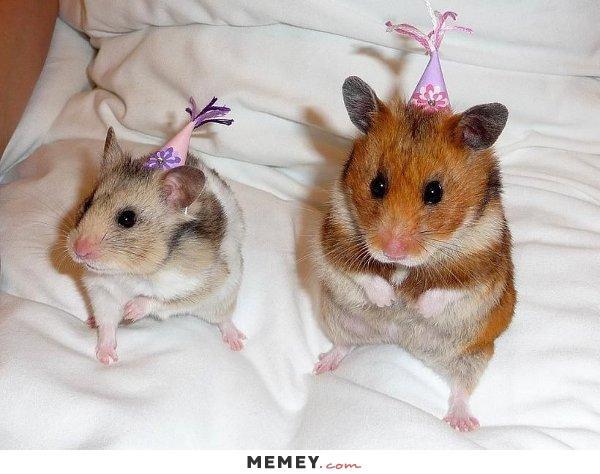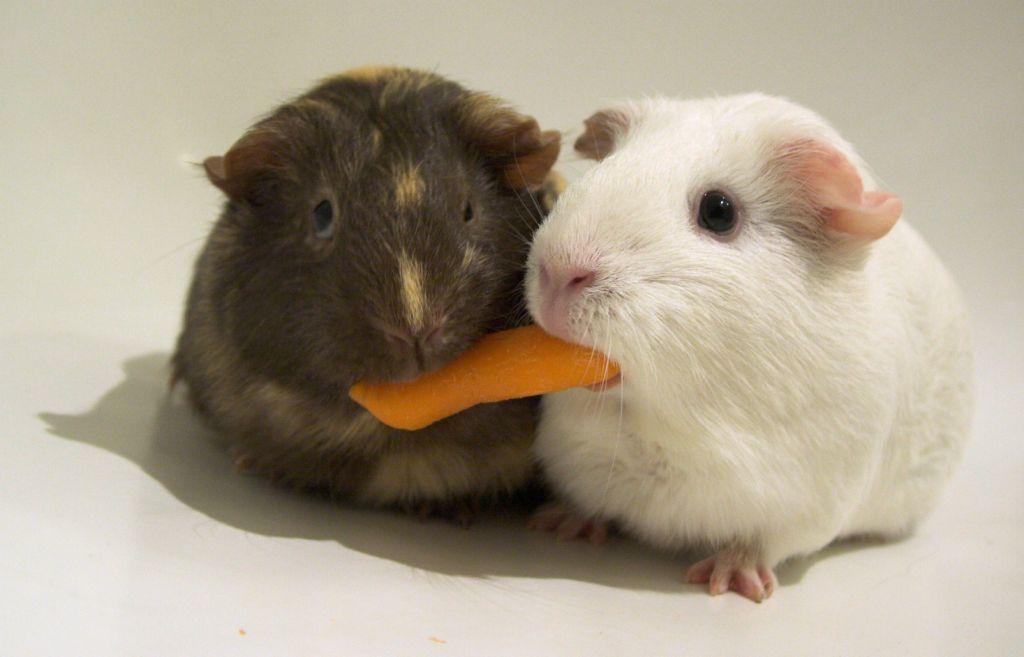The first image is the image on the left, the second image is the image on the right. Examine the images to the left and right. Is the description "There are fewer than four hamsters." accurate? Answer yes or no. No. The first image is the image on the left, the second image is the image on the right. Examine the images to the left and right. Is the description "In one of the images, there is an orange food item being eaten." accurate? Answer yes or no. Yes. 